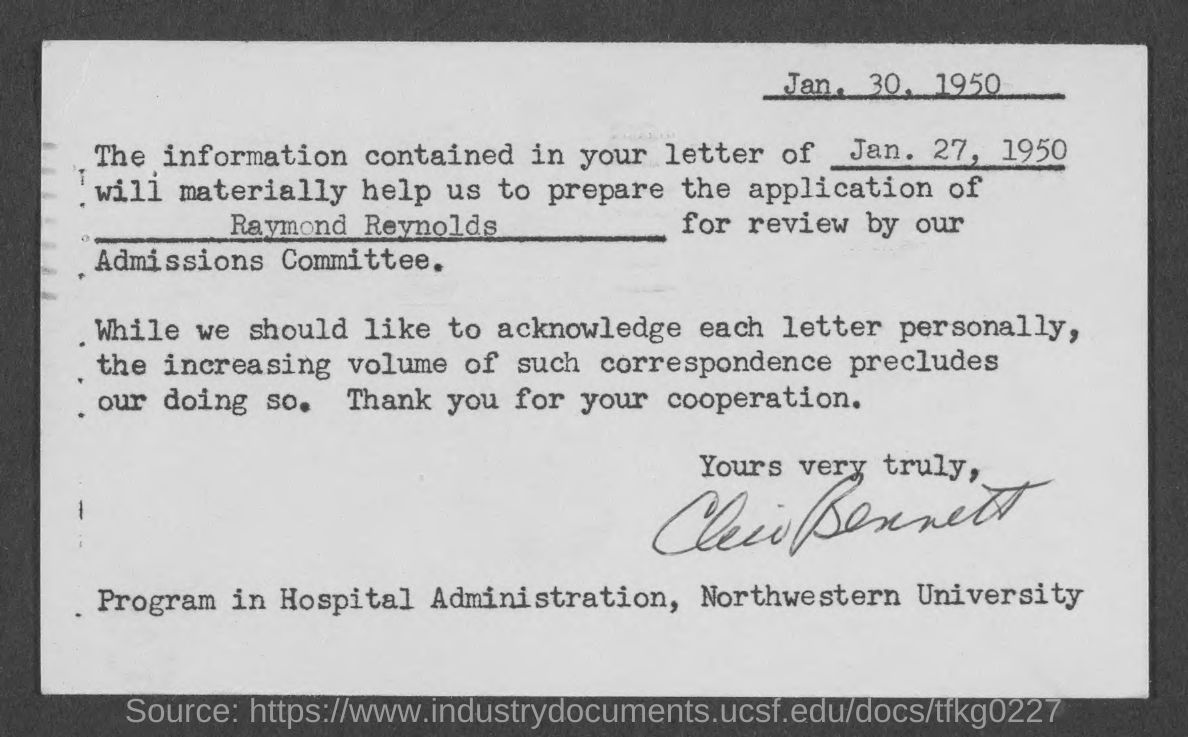What is the document dated?
Your response must be concise. Jan. 30, 1950. 